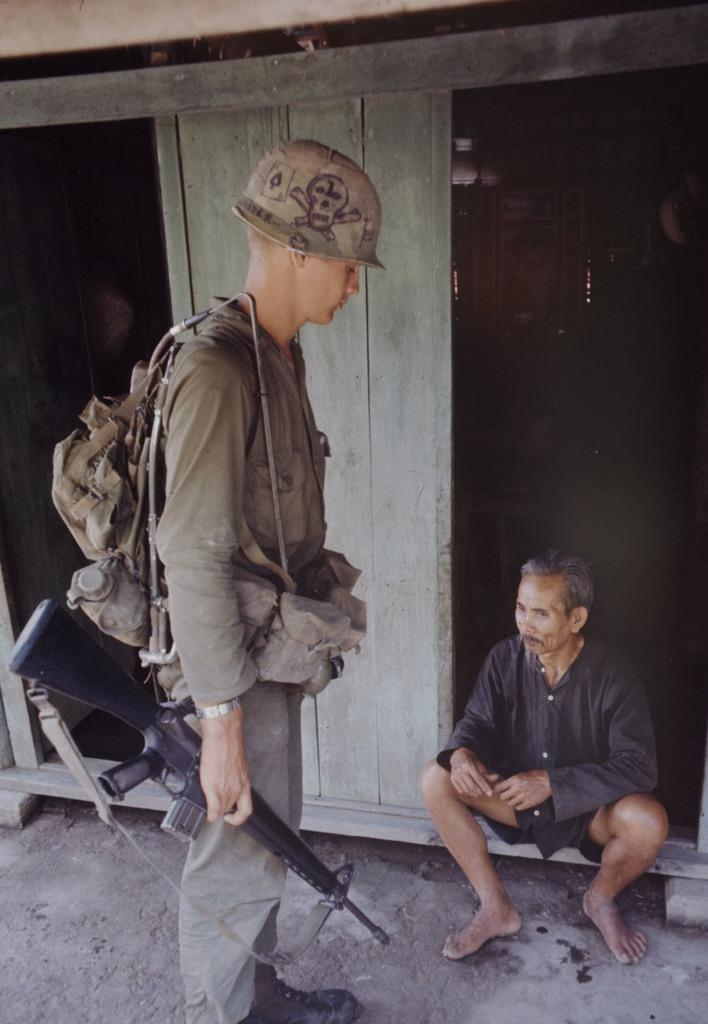What is the person in the image holding? The person in the image is holding a gun. What else can be seen on the person holding the gun? The person holding the gun is wearing a bag. What is the position of the second person in the image? The second person is sitting in front of a door. What material is the door made of? The door is made of wood. What type of fork is being used to blow the crate in the image? There is no fork, blow, or crate present in the image. 